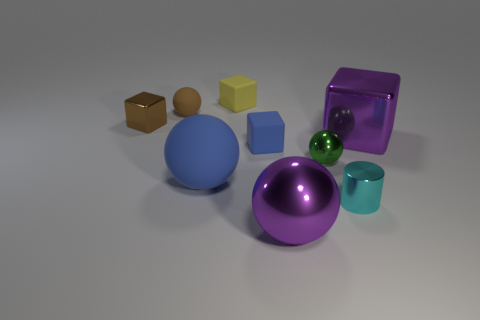Is there any sense of motion or stillness in the scene, and what contributes to that impression? The scene is predominantly still, with no discernible movement. This sense of stillness is conveyed through the careful placement of the objects, the absence of dynamic elements like shadows suggesting motion, and the lack of blur that would imply movement. The light source is consistent, casting steady shadows that ground the objects, further reinforcing the static nature of the scene. 